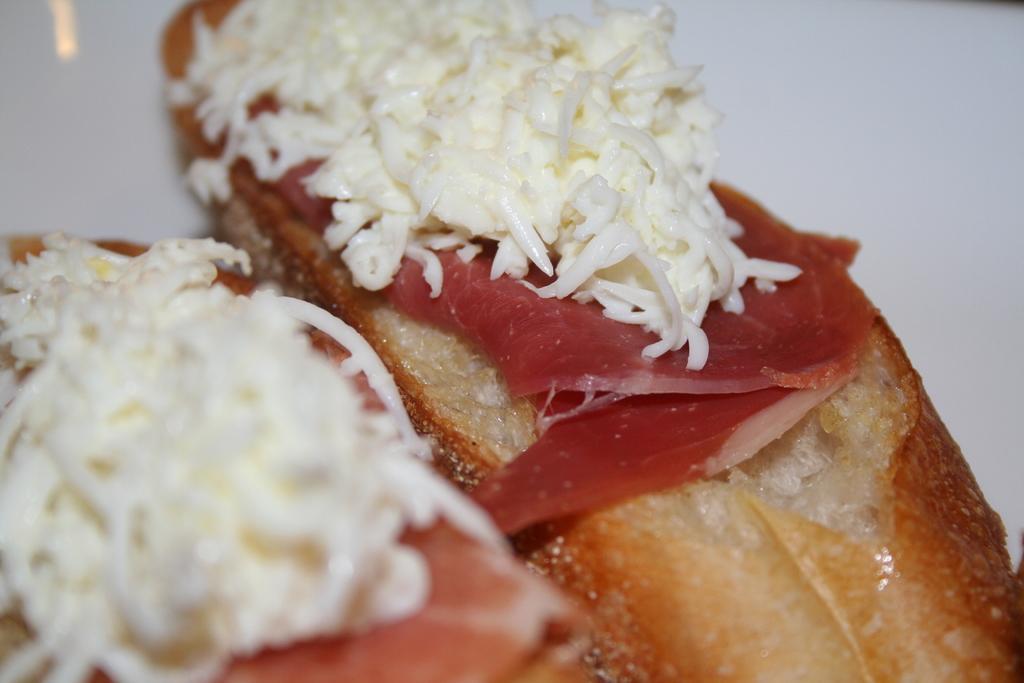Please provide a concise description of this image. At the bottom of this image, there are food items arranged. And the background is white in color. 